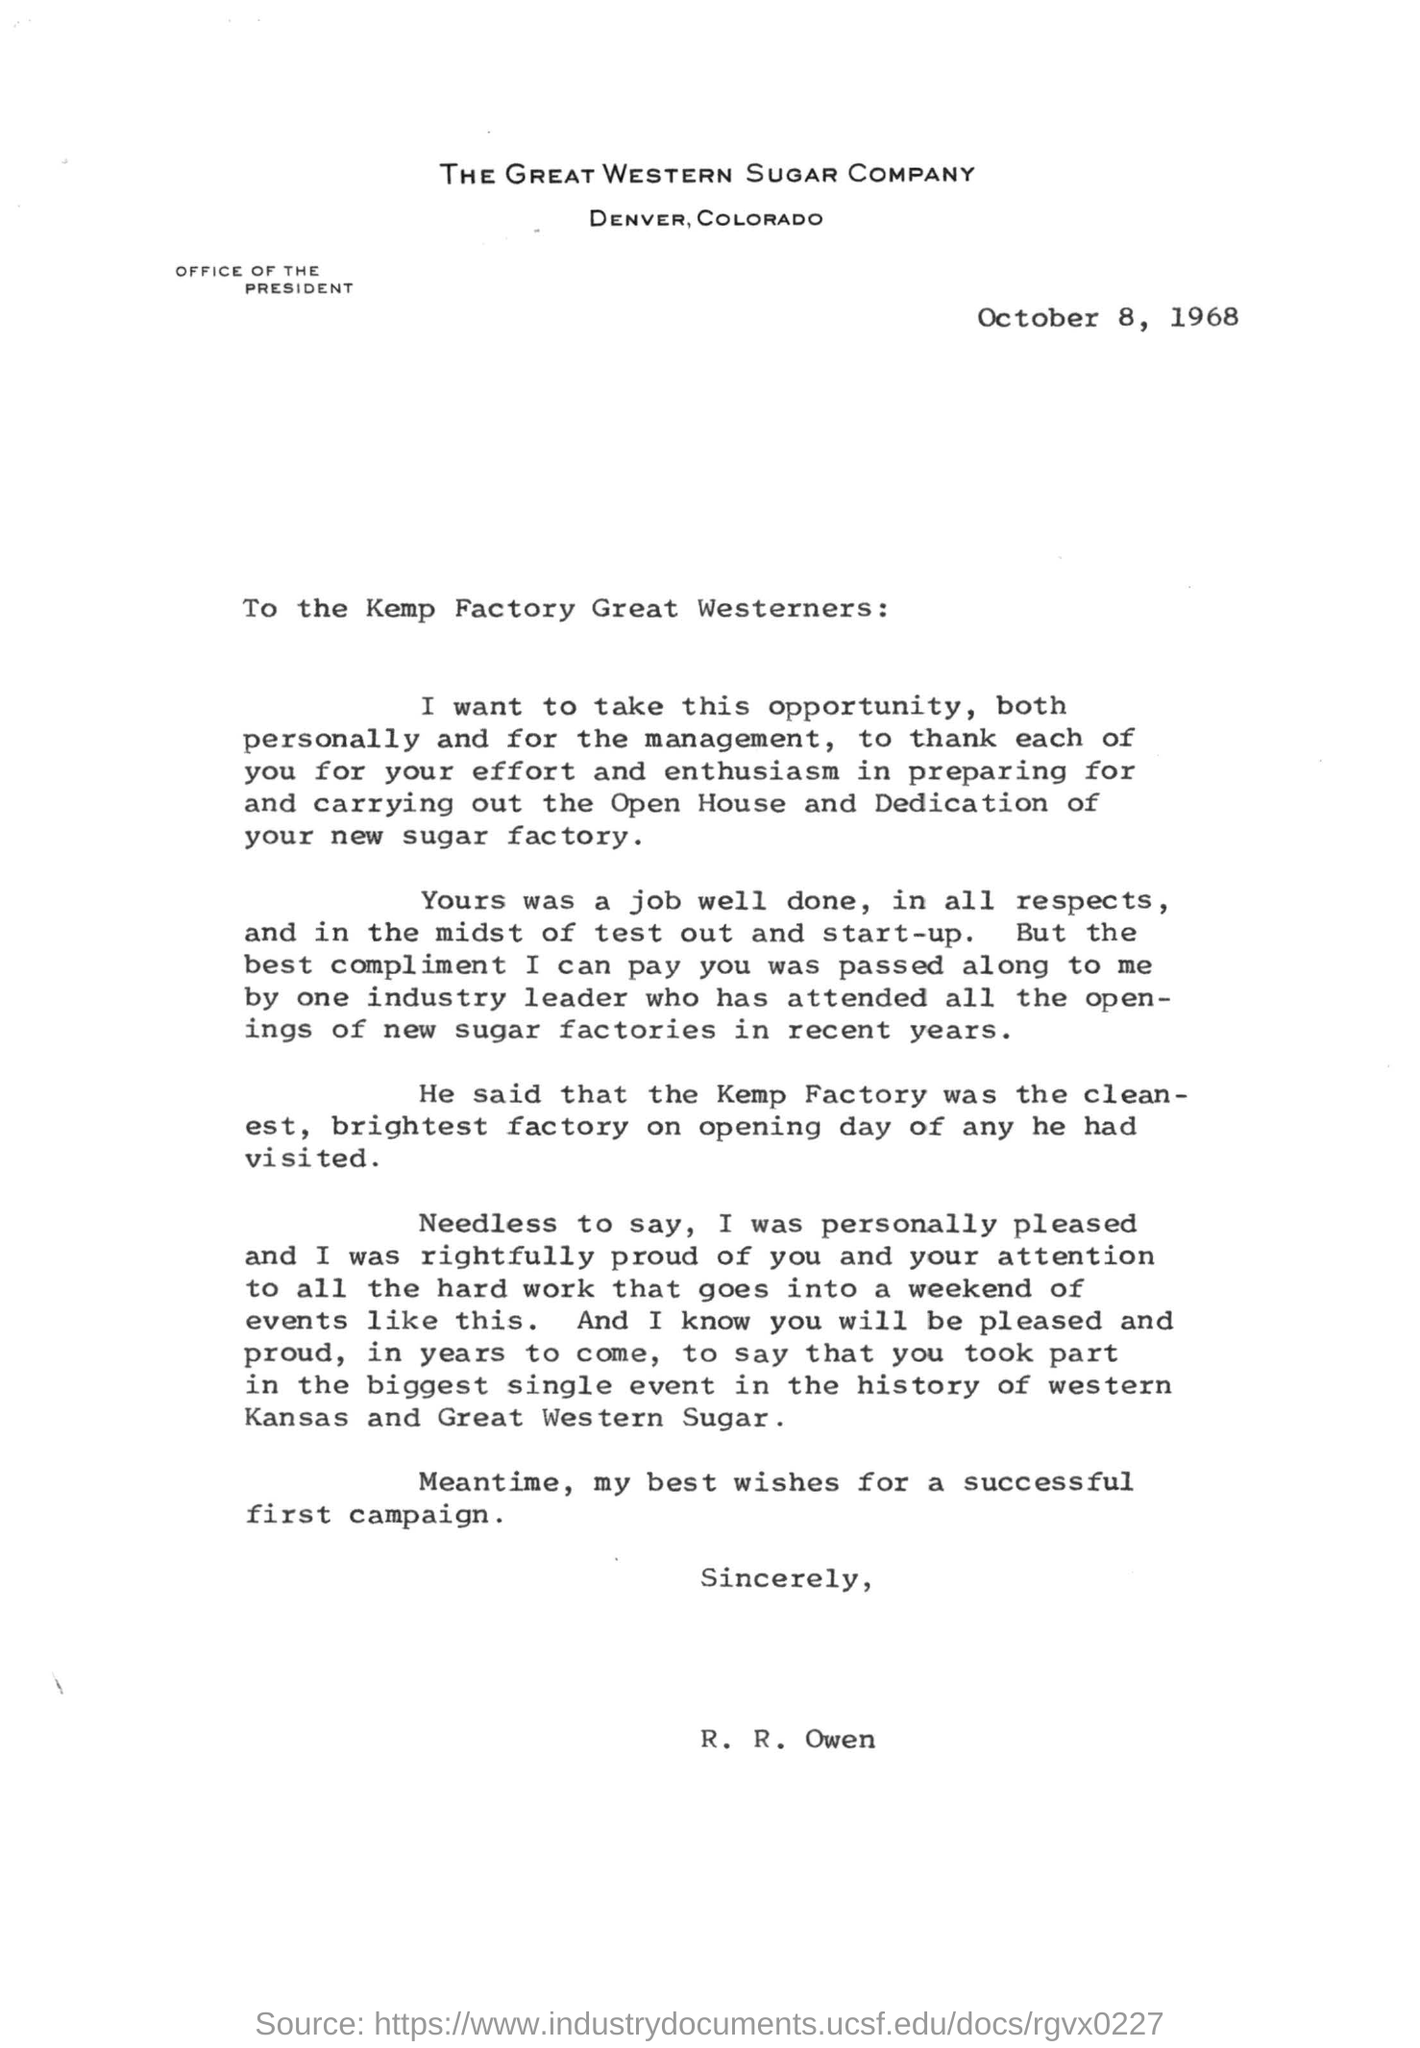What is the name of the factory?
Your response must be concise. KEMP. When is the letter dated?
Provide a succinct answer. October 8, 1968. Who wrote this letter?
Make the answer very short. R. R. Owen. 